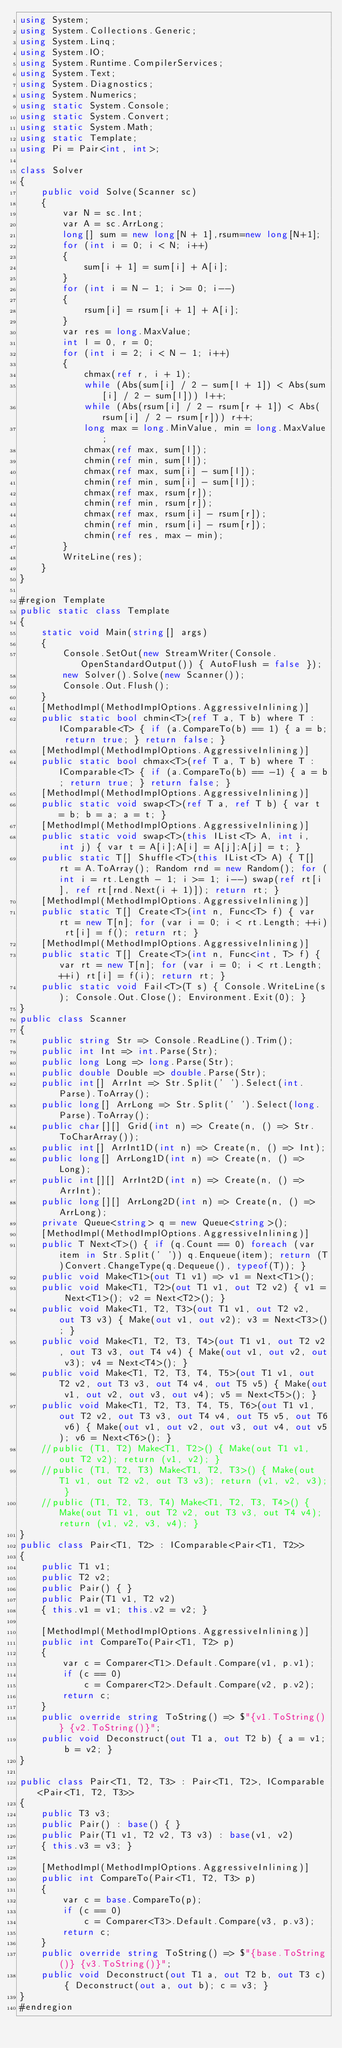<code> <loc_0><loc_0><loc_500><loc_500><_C#_>using System;
using System.Collections.Generic;
using System.Linq;
using System.IO;
using System.Runtime.CompilerServices;
using System.Text;
using System.Diagnostics;
using System.Numerics;
using static System.Console;
using static System.Convert;
using static System.Math;
using static Template;
using Pi = Pair<int, int>;

class Solver
{
    public void Solve(Scanner sc)
    {
        var N = sc.Int;
        var A = sc.ArrLong;
        long[] sum = new long[N + 1],rsum=new long[N+1];
        for (int i = 0; i < N; i++)
        {
            sum[i + 1] = sum[i] + A[i];
        }
        for (int i = N - 1; i >= 0; i--)
        {
            rsum[i] = rsum[i + 1] + A[i];
        }
        var res = long.MaxValue;
        int l = 0, r = 0;
        for (int i = 2; i < N - 1; i++)
        {
            chmax(ref r, i + 1);
            while (Abs(sum[i] / 2 - sum[l + 1]) < Abs(sum[i] / 2 - sum[l])) l++;
            while (Abs(rsum[i] / 2 - rsum[r + 1]) < Abs(rsum[i] / 2 - rsum[r])) r++;
            long max = long.MinValue, min = long.MaxValue;
            chmax(ref max, sum[l]);
            chmin(ref min, sum[l]);
            chmax(ref max, sum[i] - sum[l]);
            chmin(ref min, sum[i] - sum[l]);
            chmax(ref max, rsum[r]);
            chmin(ref min, rsum[r]);
            chmax(ref max, rsum[i] - rsum[r]);
            chmin(ref min, rsum[i] - rsum[r]);
            chmin(ref res, max - min);
        }
        WriteLine(res);
    }
}

#region Template
public static class Template
{
    static void Main(string[] args)
    {
        Console.SetOut(new StreamWriter(Console.OpenStandardOutput()) { AutoFlush = false });
        new Solver().Solve(new Scanner());
        Console.Out.Flush();
    }
    [MethodImpl(MethodImplOptions.AggressiveInlining)]
    public static bool chmin<T>(ref T a, T b) where T : IComparable<T> { if (a.CompareTo(b) == 1) { a = b; return true; } return false; }
    [MethodImpl(MethodImplOptions.AggressiveInlining)]
    public static bool chmax<T>(ref T a, T b) where T : IComparable<T> { if (a.CompareTo(b) == -1) { a = b; return true; } return false; }
    [MethodImpl(MethodImplOptions.AggressiveInlining)]
    public static void swap<T>(ref T a, ref T b) { var t = b; b = a; a = t; }
    [MethodImpl(MethodImplOptions.AggressiveInlining)]
    public static void swap<T>(this IList<T> A, int i, int j) { var t = A[i];A[i] = A[j];A[j] = t; }
    public static T[] Shuffle<T>(this IList<T> A) { T[] rt = A.ToArray(); Random rnd = new Random(); for (int i = rt.Length - 1; i >= 1; i--) swap(ref rt[i], ref rt[rnd.Next(i + 1)]); return rt; }
    [MethodImpl(MethodImplOptions.AggressiveInlining)]
    public static T[] Create<T>(int n, Func<T> f) { var rt = new T[n]; for (var i = 0; i < rt.Length; ++i) rt[i] = f(); return rt; }
    [MethodImpl(MethodImplOptions.AggressiveInlining)]
    public static T[] Create<T>(int n, Func<int, T> f) { var rt = new T[n]; for (var i = 0; i < rt.Length; ++i) rt[i] = f(i); return rt; }
    public static void Fail<T>(T s) { Console.WriteLine(s); Console.Out.Close(); Environment.Exit(0); }
}
public class Scanner
{
    public string Str => Console.ReadLine().Trim();
    public int Int => int.Parse(Str);
    public long Long => long.Parse(Str);
    public double Double => double.Parse(Str);
    public int[] ArrInt => Str.Split(' ').Select(int.Parse).ToArray();
    public long[] ArrLong => Str.Split(' ').Select(long.Parse).ToArray();
    public char[][] Grid(int n) => Create(n, () => Str.ToCharArray());
    public int[] ArrInt1D(int n) => Create(n, () => Int);
    public long[] ArrLong1D(int n) => Create(n, () => Long);
    public int[][] ArrInt2D(int n) => Create(n, () => ArrInt);
    public long[][] ArrLong2D(int n) => Create(n, () => ArrLong);
    private Queue<string> q = new Queue<string>();
    [MethodImpl(MethodImplOptions.AggressiveInlining)]
    public T Next<T>() { if (q.Count == 0) foreach (var item in Str.Split(' ')) q.Enqueue(item); return (T)Convert.ChangeType(q.Dequeue(), typeof(T)); }
    public void Make<T1>(out T1 v1) => v1 = Next<T1>();
    public void Make<T1, T2>(out T1 v1, out T2 v2) { v1 = Next<T1>(); v2 = Next<T2>(); }
    public void Make<T1, T2, T3>(out T1 v1, out T2 v2, out T3 v3) { Make(out v1, out v2); v3 = Next<T3>(); }
    public void Make<T1, T2, T3, T4>(out T1 v1, out T2 v2, out T3 v3, out T4 v4) { Make(out v1, out v2, out v3); v4 = Next<T4>(); }
    public void Make<T1, T2, T3, T4, T5>(out T1 v1, out T2 v2, out T3 v3, out T4 v4, out T5 v5) { Make(out v1, out v2, out v3, out v4); v5 = Next<T5>(); }
    public void Make<T1, T2, T3, T4, T5, T6>(out T1 v1, out T2 v2, out T3 v3, out T4 v4, out T5 v5, out T6 v6) { Make(out v1, out v2, out v3, out v4, out v5); v6 = Next<T6>(); }
    //public (T1, T2) Make<T1, T2>() { Make(out T1 v1, out T2 v2); return (v1, v2); }
    //public (T1, T2, T3) Make<T1, T2, T3>() { Make(out T1 v1, out T2 v2, out T3 v3); return (v1, v2, v3); }
    //public (T1, T2, T3, T4) Make<T1, T2, T3, T4>() { Make(out T1 v1, out T2 v2, out T3 v3, out T4 v4); return (v1, v2, v3, v4); }
}
public class Pair<T1, T2> : IComparable<Pair<T1, T2>>
{
    public T1 v1;
    public T2 v2;
    public Pair() { }
    public Pair(T1 v1, T2 v2)
    { this.v1 = v1; this.v2 = v2; }

    [MethodImpl(MethodImplOptions.AggressiveInlining)]
    public int CompareTo(Pair<T1, T2> p)
    {
        var c = Comparer<T1>.Default.Compare(v1, p.v1);
        if (c == 0)
            c = Comparer<T2>.Default.Compare(v2, p.v2);
        return c;
    }
    public override string ToString() => $"{v1.ToString()} {v2.ToString()}";
    public void Deconstruct(out T1 a, out T2 b) { a = v1; b = v2; }
}

public class Pair<T1, T2, T3> : Pair<T1, T2>, IComparable<Pair<T1, T2, T3>>
{
    public T3 v3;
    public Pair() : base() { }
    public Pair(T1 v1, T2 v2, T3 v3) : base(v1, v2)
    { this.v3 = v3; }

    [MethodImpl(MethodImplOptions.AggressiveInlining)]
    public int CompareTo(Pair<T1, T2, T3> p)
    {
        var c = base.CompareTo(p);
        if (c == 0)
            c = Comparer<T3>.Default.Compare(v3, p.v3);
        return c;
    }
    public override string ToString() => $"{base.ToString()} {v3.ToString()}";
    public void Deconstruct(out T1 a, out T2 b, out T3 c) { Deconstruct(out a, out b); c = v3; }
}
#endregion</code> 